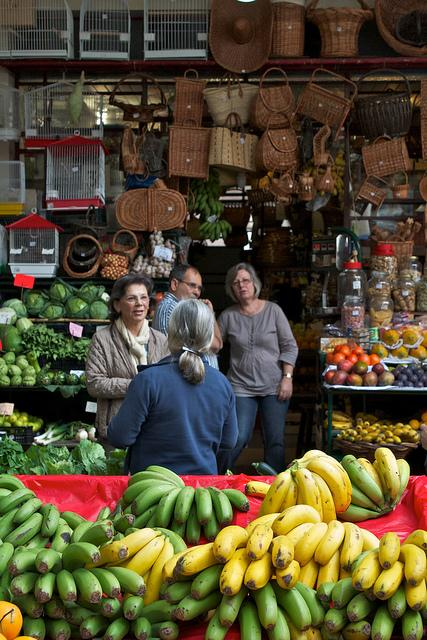What is meant to be kept in those cages?

Choices:
A) snakes
B) lizards
C) rabbits
D) birds birds 